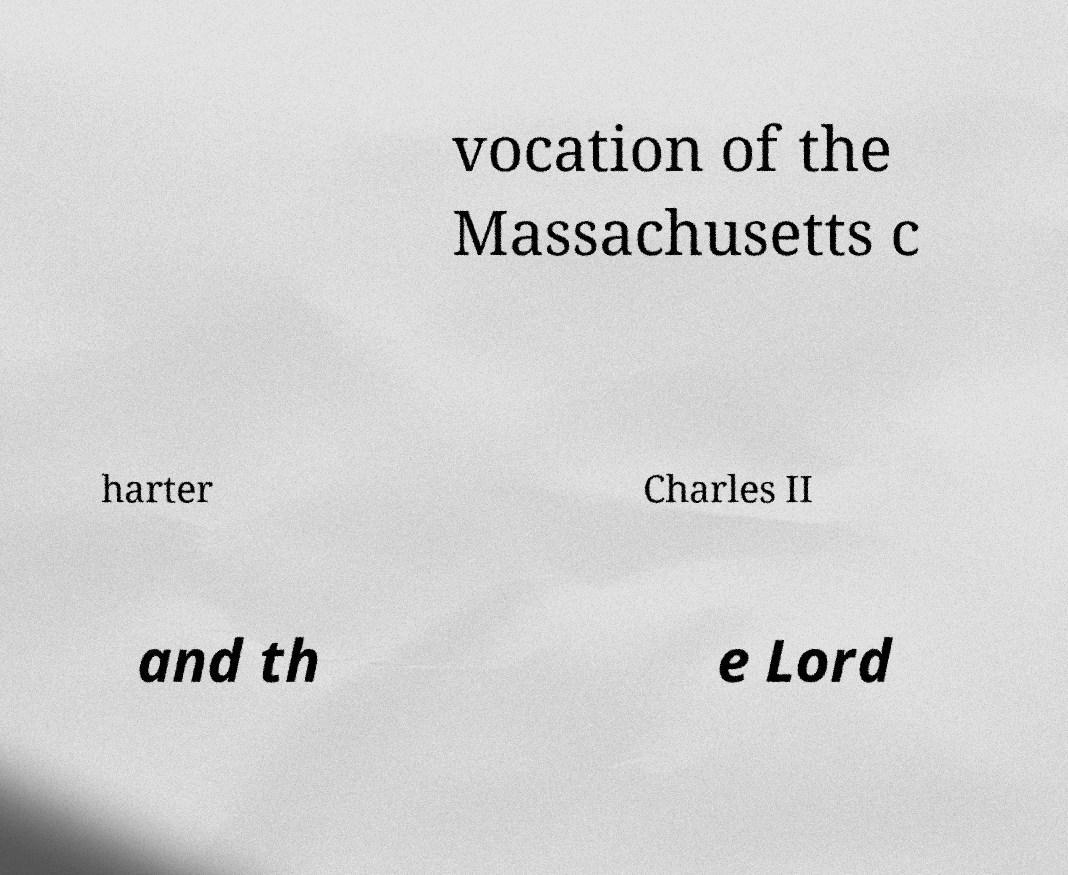I need the written content from this picture converted into text. Can you do that? vocation of the Massachusetts c harter Charles II and th e Lord 